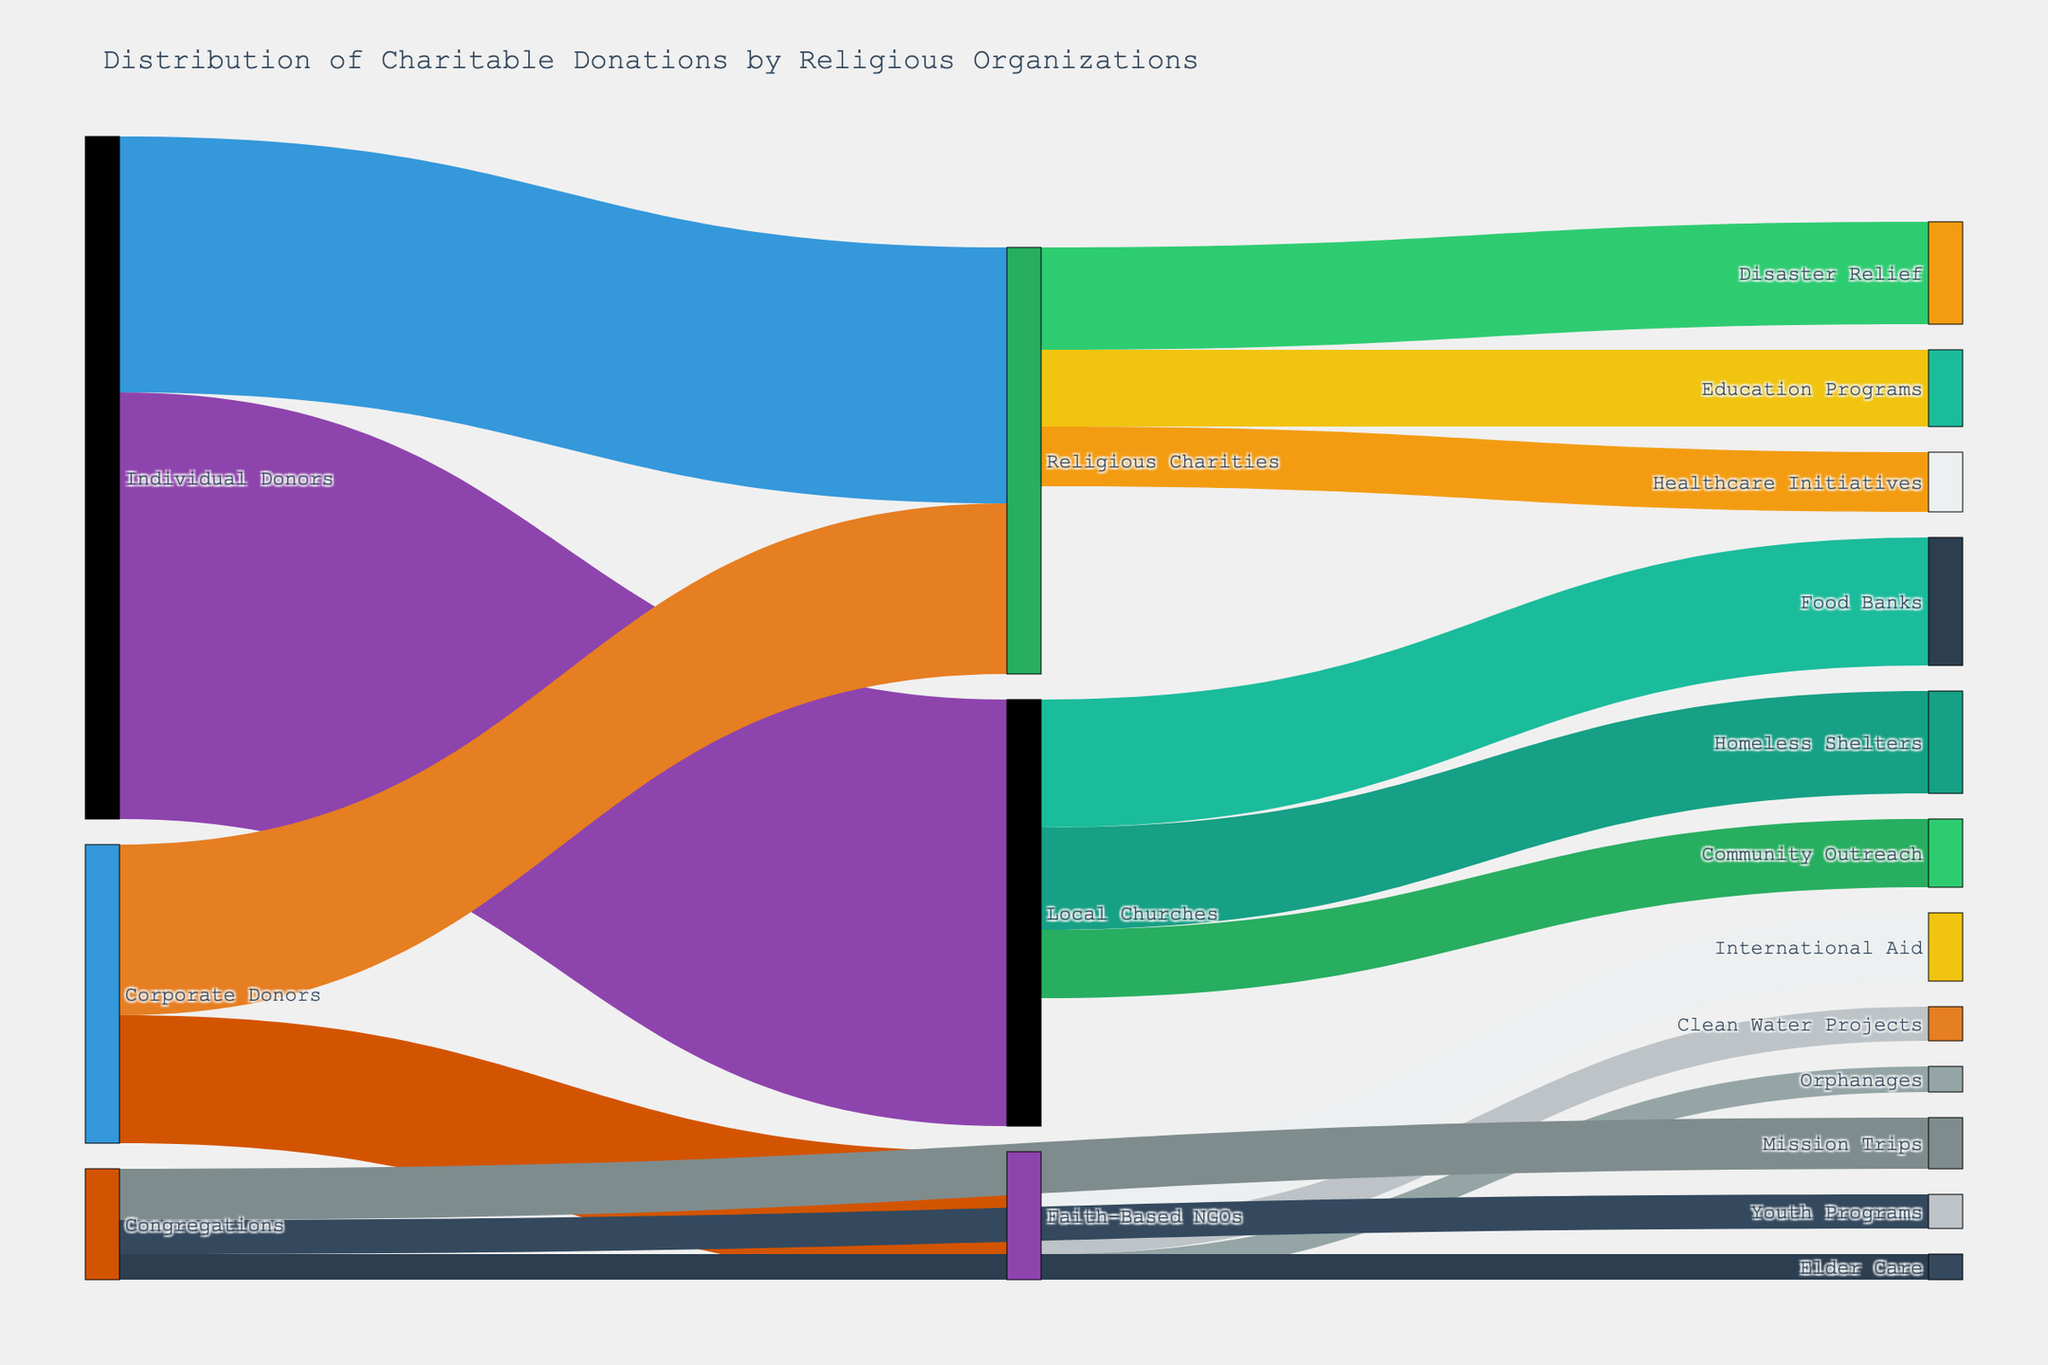What does the title of the figure indicate? The title of the figure provides a clear summary of the content, explaining that the diagram displays how charitable donations are distributed by religious organizations and flows from donors to various causes.
Answer: Distribution of Charitable Donations by Religious Organizations Which group received the highest donations from individual donors? The figure shows donations flowing from 'Individual Donors' to 'Local Churches' and 'Religious Charities'. The largest flow from individual donors is directed towards 'Local Churches' with a value of 5,000,000.
Answer: Local Churches How much total donation do Religious Charities receive from both individual and corporate donors? To get the total donations received by Religious Charities, sum the values of donations from individual donors (3,000,000) and corporate donors (2,000,000). Thus, 3,000,000 + 2,000,000 = 5,000,000.
Answer: 5,000,000 Which cause received the least donations from Faith-Based NGOs? According to the diagram, 'Faith-Based NGOs' distribute donations to 'International Aid', 'Clean Water Projects', and 'Orphanages'. 'Orphanages' received the smallest donation amount of 300,000.
Answer: Orphanages How do the donations from Corporate Donors compare to those from Individual Donors to Religious Charities? By observing the flows, we see that Corporate Donors give 2,000,000 to Religious Charities while Individual Donors give 3,000,000 to Religious Charities. Thus, Individual Donors contribute more.
Answer: Individual Donors give more What is the combined donation amount from Local Churches to Food Banks and Homeless Shelters? The flow from Local Churches to Food Banks is 1,500,000 and to Homeless Shelters is 1,200,000. Adding these gives 1,500,000 + 1,200,000 = 2,700,000.
Answer: 2,700,000 Which donor group contributes to Mission Trips and what is the amount? By following the flows, we see that 'Congregations' contribute to 'Mission Trips' with the amount of 600,000.
Answer: Congregations, 600,000 How does the amount donated by Religious Charities to Healthcare Initiatives compare to Community Outreach donations from Local Churches? Religious Charities donate 700,000 to Healthcare Initiatives and Local Churches donate 800,000 to Community Outreach. Thus, Local Churches donate more to Community Outreach.
Answer: Local Churches donate more What is the ratio of donations from Faith-Based NGOs to International Aid versus Clean Water Projects? Faith-Based NGOs donate 800,000 to International Aid and 400,000 to Clean Water Projects. The ratio is thus 800,000:400,000, which simplifies to 2:1.
Answer: 2:1 